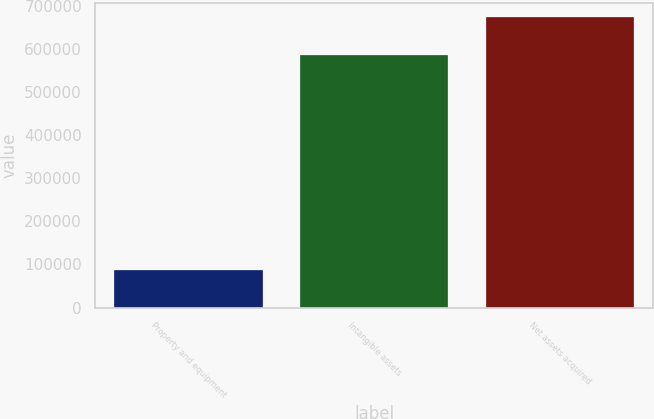Convert chart. <chart><loc_0><loc_0><loc_500><loc_500><bar_chart><fcel>Property and equipment<fcel>Intangible assets<fcel>Net assets acquired<nl><fcel>86787<fcel>587111<fcel>673898<nl></chart> 